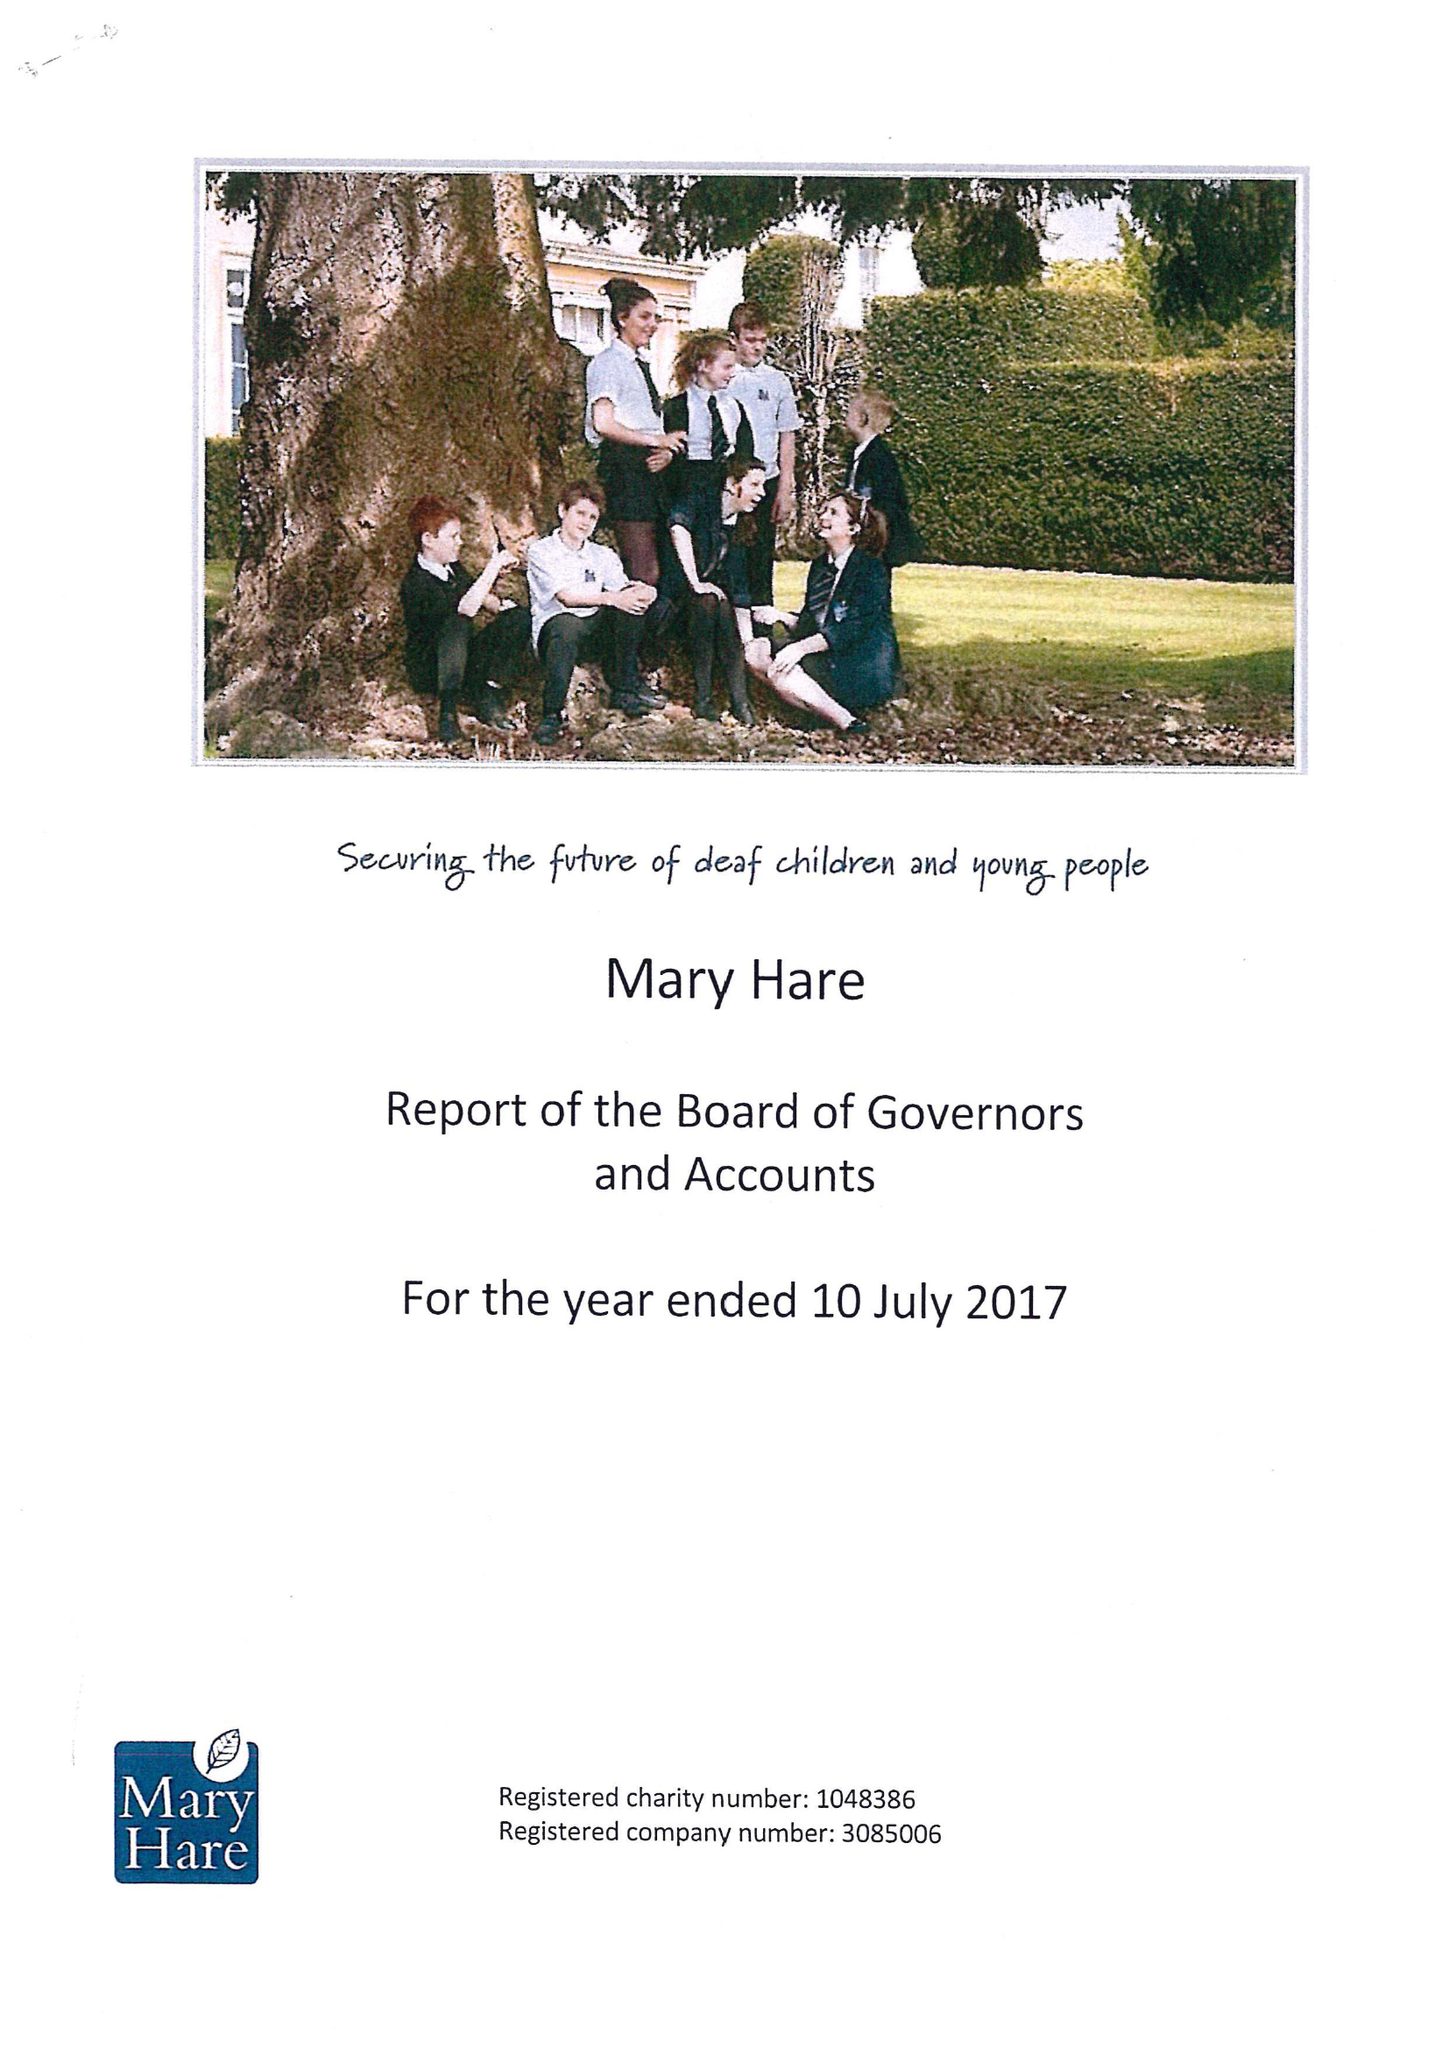What is the value for the income_annually_in_british_pounds?
Answer the question using a single word or phrase. 12626000.00 